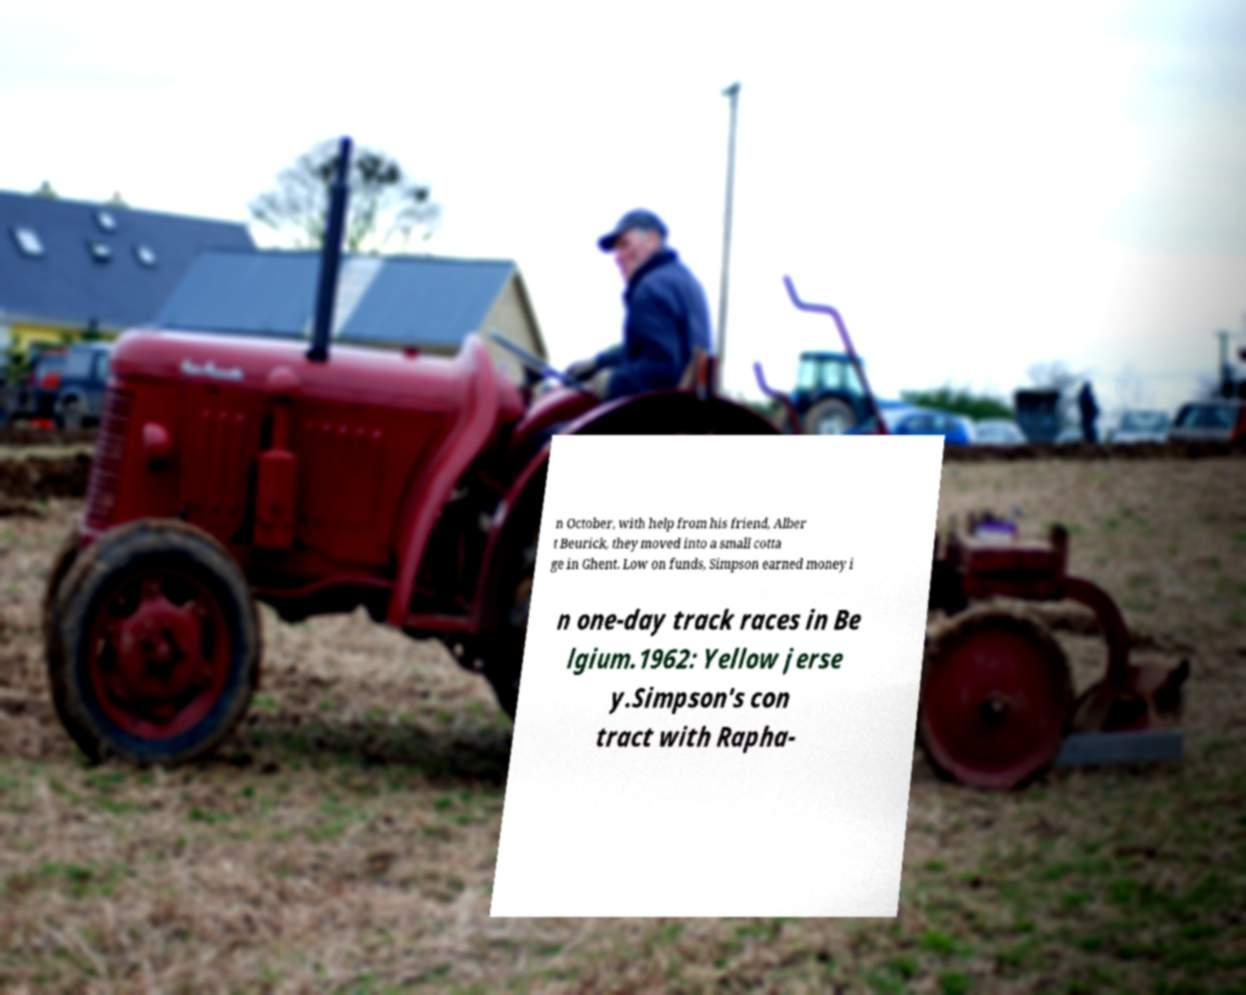Can you read and provide the text displayed in the image?This photo seems to have some interesting text. Can you extract and type it out for me? n October, with help from his friend, Alber t Beurick, they moved into a small cotta ge in Ghent. Low on funds, Simpson earned money i n one-day track races in Be lgium.1962: Yellow jerse y.Simpson's con tract with Rapha- 